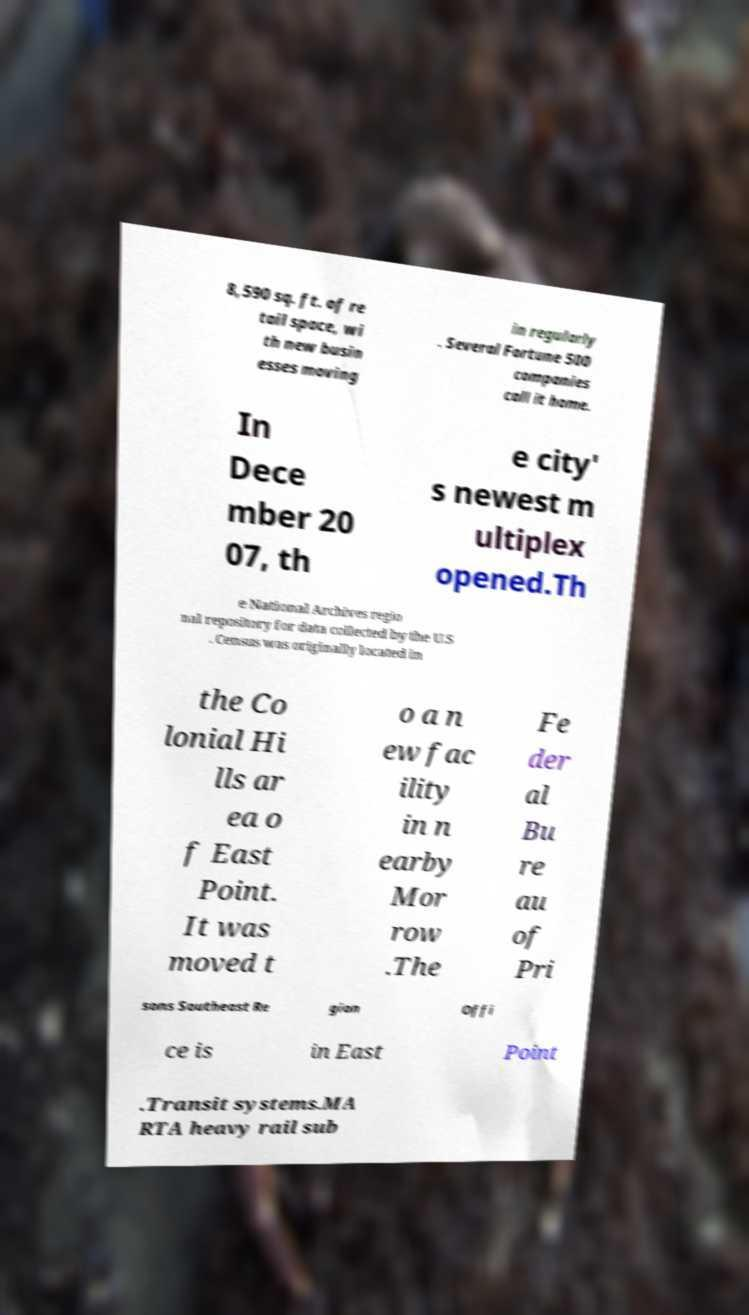There's text embedded in this image that I need extracted. Can you transcribe it verbatim? 8,590 sq. ft. of re tail space, wi th new busin esses moving in regularly . Several Fortune 500 companies call it home. In Dece mber 20 07, th e city' s newest m ultiplex opened.Th e National Archives regio nal repository for data collected by the U.S . Census was originally located in the Co lonial Hi lls ar ea o f East Point. It was moved t o a n ew fac ility in n earby Mor row .The Fe der al Bu re au of Pri sons Southeast Re gion Offi ce is in East Point .Transit systems.MA RTA heavy rail sub 